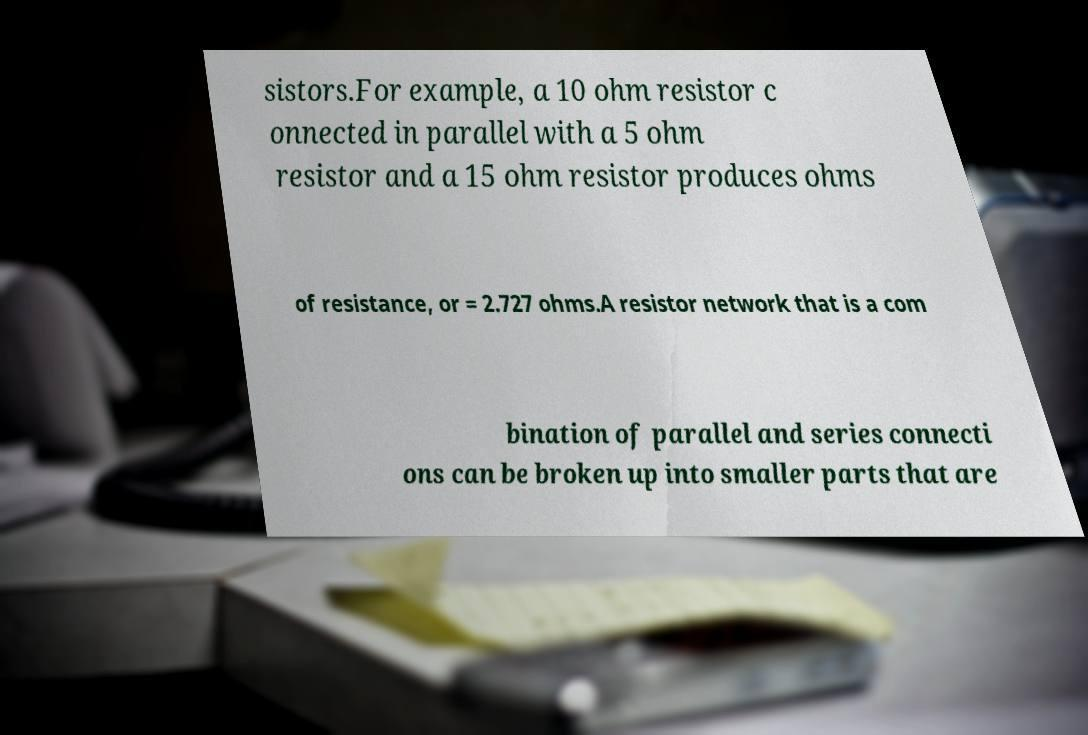Could you assist in decoding the text presented in this image and type it out clearly? sistors.For example, a 10 ohm resistor c onnected in parallel with a 5 ohm resistor and a 15 ohm resistor produces ohms of resistance, or = 2.727 ohms.A resistor network that is a com bination of parallel and series connecti ons can be broken up into smaller parts that are 